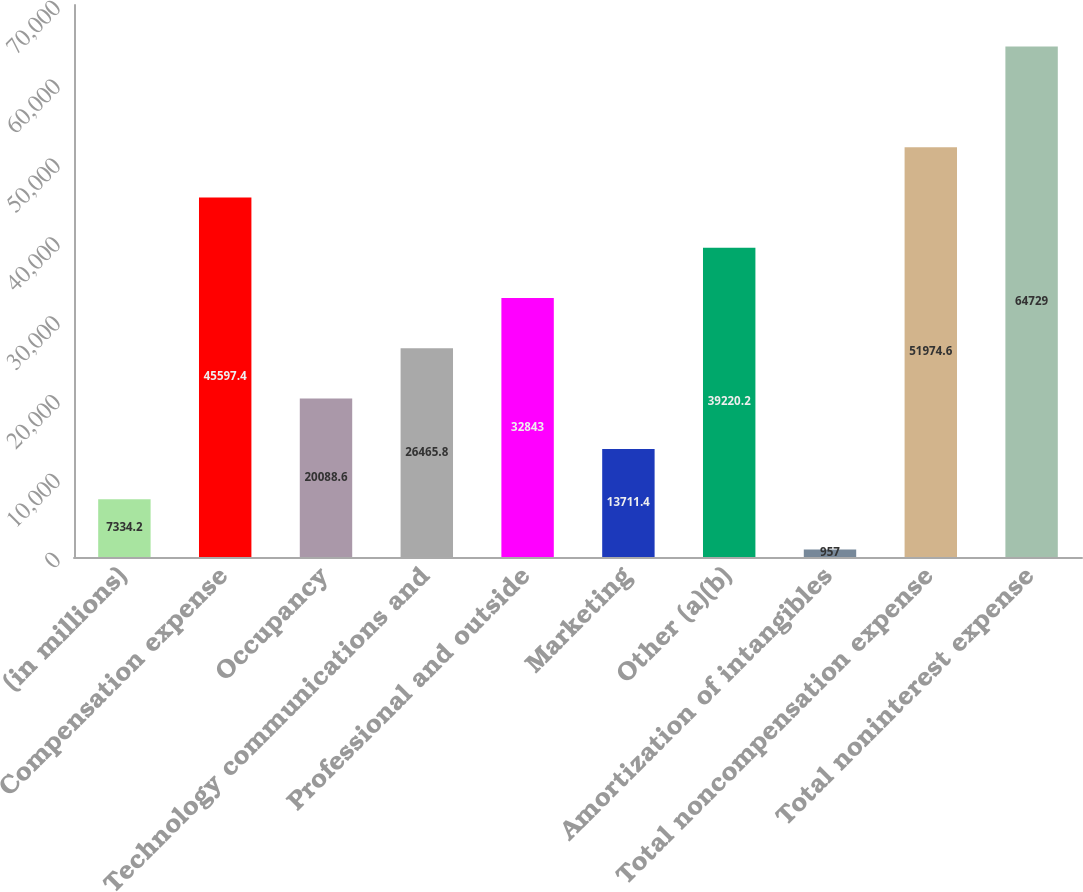Convert chart to OTSL. <chart><loc_0><loc_0><loc_500><loc_500><bar_chart><fcel>(in millions)<fcel>Compensation expense<fcel>Occupancy<fcel>Technology communications and<fcel>Professional and outside<fcel>Marketing<fcel>Other (a)(b)<fcel>Amortization of intangibles<fcel>Total noncompensation expense<fcel>Total noninterest expense<nl><fcel>7334.2<fcel>45597.4<fcel>20088.6<fcel>26465.8<fcel>32843<fcel>13711.4<fcel>39220.2<fcel>957<fcel>51974.6<fcel>64729<nl></chart> 